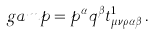Convert formula to latex. <formula><loc_0><loc_0><loc_500><loc_500>\ g a m p = p ^ { \alpha } q ^ { \beta } t ^ { 1 } _ { \mu \nu \rho \alpha \beta } \, .</formula> 